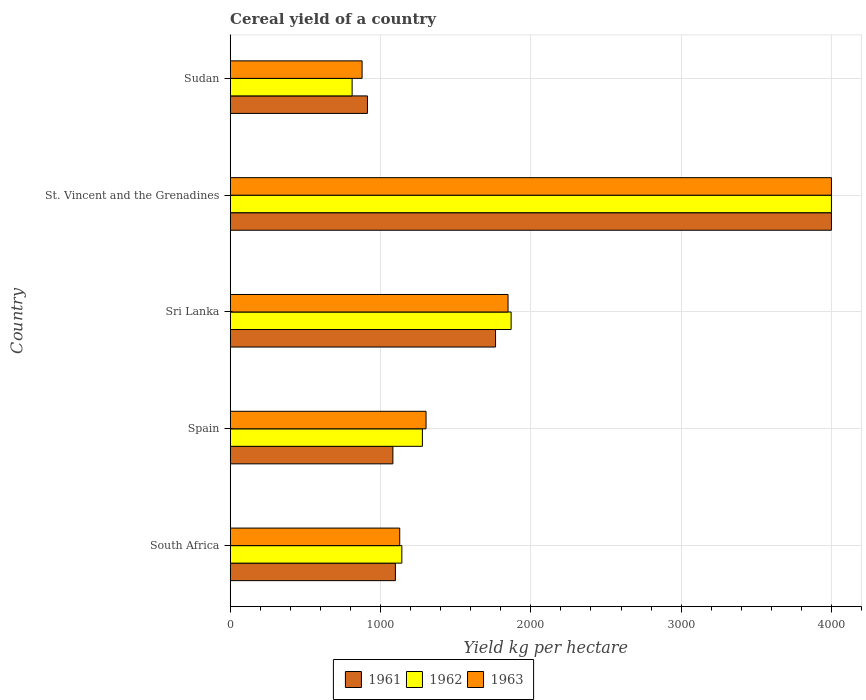Are the number of bars on each tick of the Y-axis equal?
Offer a terse response. Yes. What is the label of the 4th group of bars from the top?
Keep it short and to the point. Spain. In how many cases, is the number of bars for a given country not equal to the number of legend labels?
Your answer should be very brief. 0. What is the total cereal yield in 1963 in Sudan?
Offer a terse response. 877.56. Across all countries, what is the maximum total cereal yield in 1962?
Your response must be concise. 4000. Across all countries, what is the minimum total cereal yield in 1962?
Offer a terse response. 811.23. In which country was the total cereal yield in 1961 maximum?
Ensure brevity in your answer.  St. Vincent and the Grenadines. In which country was the total cereal yield in 1962 minimum?
Make the answer very short. Sudan. What is the total total cereal yield in 1962 in the graph?
Offer a very short reply. 9101.1. What is the difference between the total cereal yield in 1961 in Spain and that in Sudan?
Offer a terse response. 169.38. What is the difference between the total cereal yield in 1961 in Sri Lanka and the total cereal yield in 1962 in Spain?
Provide a short and direct response. 486.72. What is the average total cereal yield in 1961 per country?
Provide a short and direct response. 1772.03. What is the difference between the total cereal yield in 1961 and total cereal yield in 1963 in St. Vincent and the Grenadines?
Give a very brief answer. 0. What is the ratio of the total cereal yield in 1962 in South Africa to that in Sudan?
Ensure brevity in your answer.  1.41. What is the difference between the highest and the second highest total cereal yield in 1961?
Give a very brief answer. 2234.57. What is the difference between the highest and the lowest total cereal yield in 1962?
Provide a short and direct response. 3188.78. Is the sum of the total cereal yield in 1961 in Sri Lanka and St. Vincent and the Grenadines greater than the maximum total cereal yield in 1963 across all countries?
Provide a succinct answer. Yes. What does the 2nd bar from the top in South Africa represents?
Offer a terse response. 1962. Is it the case that in every country, the sum of the total cereal yield in 1963 and total cereal yield in 1962 is greater than the total cereal yield in 1961?
Offer a terse response. Yes. What is the difference between two consecutive major ticks on the X-axis?
Your answer should be very brief. 1000. Does the graph contain any zero values?
Offer a terse response. No. How many legend labels are there?
Give a very brief answer. 3. What is the title of the graph?
Ensure brevity in your answer.  Cereal yield of a country. Does "1991" appear as one of the legend labels in the graph?
Your answer should be very brief. No. What is the label or title of the X-axis?
Provide a succinct answer. Yield kg per hectare. What is the label or title of the Y-axis?
Provide a succinct answer. Country. What is the Yield kg per hectare of 1961 in South Africa?
Your answer should be compact. 1099.14. What is the Yield kg per hectare in 1962 in South Africa?
Keep it short and to the point. 1142.06. What is the Yield kg per hectare in 1963 in South Africa?
Provide a short and direct response. 1128.02. What is the Yield kg per hectare of 1961 in Spain?
Keep it short and to the point. 1082.47. What is the Yield kg per hectare in 1962 in Spain?
Offer a very short reply. 1278.71. What is the Yield kg per hectare in 1963 in Spain?
Give a very brief answer. 1303.07. What is the Yield kg per hectare in 1961 in Sri Lanka?
Give a very brief answer. 1765.43. What is the Yield kg per hectare in 1962 in Sri Lanka?
Your response must be concise. 1869.1. What is the Yield kg per hectare in 1963 in Sri Lanka?
Your answer should be compact. 1848.43. What is the Yield kg per hectare in 1961 in St. Vincent and the Grenadines?
Ensure brevity in your answer.  4000. What is the Yield kg per hectare of 1962 in St. Vincent and the Grenadines?
Ensure brevity in your answer.  4000. What is the Yield kg per hectare in 1963 in St. Vincent and the Grenadines?
Provide a short and direct response. 4000. What is the Yield kg per hectare of 1961 in Sudan?
Make the answer very short. 913.1. What is the Yield kg per hectare of 1962 in Sudan?
Your answer should be compact. 811.23. What is the Yield kg per hectare in 1963 in Sudan?
Your answer should be compact. 877.56. Across all countries, what is the maximum Yield kg per hectare of 1961?
Offer a terse response. 4000. Across all countries, what is the maximum Yield kg per hectare of 1962?
Ensure brevity in your answer.  4000. Across all countries, what is the maximum Yield kg per hectare of 1963?
Provide a succinct answer. 4000. Across all countries, what is the minimum Yield kg per hectare of 1961?
Make the answer very short. 913.1. Across all countries, what is the minimum Yield kg per hectare in 1962?
Your answer should be very brief. 811.23. Across all countries, what is the minimum Yield kg per hectare of 1963?
Offer a very short reply. 877.56. What is the total Yield kg per hectare of 1961 in the graph?
Give a very brief answer. 8860.14. What is the total Yield kg per hectare in 1962 in the graph?
Provide a succinct answer. 9101.1. What is the total Yield kg per hectare of 1963 in the graph?
Your answer should be very brief. 9157.08. What is the difference between the Yield kg per hectare in 1961 in South Africa and that in Spain?
Provide a short and direct response. 16.67. What is the difference between the Yield kg per hectare in 1962 in South Africa and that in Spain?
Your answer should be very brief. -136.65. What is the difference between the Yield kg per hectare in 1963 in South Africa and that in Spain?
Ensure brevity in your answer.  -175.04. What is the difference between the Yield kg per hectare in 1961 in South Africa and that in Sri Lanka?
Give a very brief answer. -666.29. What is the difference between the Yield kg per hectare in 1962 in South Africa and that in Sri Lanka?
Your answer should be very brief. -727.04. What is the difference between the Yield kg per hectare in 1963 in South Africa and that in Sri Lanka?
Your response must be concise. -720.41. What is the difference between the Yield kg per hectare of 1961 in South Africa and that in St. Vincent and the Grenadines?
Your answer should be very brief. -2900.86. What is the difference between the Yield kg per hectare of 1962 in South Africa and that in St. Vincent and the Grenadines?
Provide a succinct answer. -2857.94. What is the difference between the Yield kg per hectare in 1963 in South Africa and that in St. Vincent and the Grenadines?
Offer a very short reply. -2871.98. What is the difference between the Yield kg per hectare in 1961 in South Africa and that in Sudan?
Keep it short and to the point. 186.05. What is the difference between the Yield kg per hectare in 1962 in South Africa and that in Sudan?
Give a very brief answer. 330.84. What is the difference between the Yield kg per hectare of 1963 in South Africa and that in Sudan?
Keep it short and to the point. 250.46. What is the difference between the Yield kg per hectare of 1961 in Spain and that in Sri Lanka?
Offer a terse response. -682.96. What is the difference between the Yield kg per hectare in 1962 in Spain and that in Sri Lanka?
Your answer should be very brief. -590.39. What is the difference between the Yield kg per hectare of 1963 in Spain and that in Sri Lanka?
Ensure brevity in your answer.  -545.36. What is the difference between the Yield kg per hectare in 1961 in Spain and that in St. Vincent and the Grenadines?
Offer a terse response. -2917.53. What is the difference between the Yield kg per hectare in 1962 in Spain and that in St. Vincent and the Grenadines?
Offer a terse response. -2721.29. What is the difference between the Yield kg per hectare of 1963 in Spain and that in St. Vincent and the Grenadines?
Provide a short and direct response. -2696.93. What is the difference between the Yield kg per hectare of 1961 in Spain and that in Sudan?
Your response must be concise. 169.38. What is the difference between the Yield kg per hectare in 1962 in Spain and that in Sudan?
Your answer should be very brief. 467.49. What is the difference between the Yield kg per hectare of 1963 in Spain and that in Sudan?
Your answer should be very brief. 425.5. What is the difference between the Yield kg per hectare of 1961 in Sri Lanka and that in St. Vincent and the Grenadines?
Your answer should be very brief. -2234.57. What is the difference between the Yield kg per hectare of 1962 in Sri Lanka and that in St. Vincent and the Grenadines?
Provide a short and direct response. -2130.9. What is the difference between the Yield kg per hectare in 1963 in Sri Lanka and that in St. Vincent and the Grenadines?
Provide a short and direct response. -2151.57. What is the difference between the Yield kg per hectare in 1961 in Sri Lanka and that in Sudan?
Your answer should be very brief. 852.33. What is the difference between the Yield kg per hectare in 1962 in Sri Lanka and that in Sudan?
Ensure brevity in your answer.  1057.88. What is the difference between the Yield kg per hectare of 1963 in Sri Lanka and that in Sudan?
Provide a succinct answer. 970.87. What is the difference between the Yield kg per hectare in 1961 in St. Vincent and the Grenadines and that in Sudan?
Your answer should be very brief. 3086.9. What is the difference between the Yield kg per hectare of 1962 in St. Vincent and the Grenadines and that in Sudan?
Give a very brief answer. 3188.78. What is the difference between the Yield kg per hectare of 1963 in St. Vincent and the Grenadines and that in Sudan?
Your response must be concise. 3122.44. What is the difference between the Yield kg per hectare of 1961 in South Africa and the Yield kg per hectare of 1962 in Spain?
Provide a succinct answer. -179.57. What is the difference between the Yield kg per hectare in 1961 in South Africa and the Yield kg per hectare in 1963 in Spain?
Ensure brevity in your answer.  -203.92. What is the difference between the Yield kg per hectare in 1962 in South Africa and the Yield kg per hectare in 1963 in Spain?
Make the answer very short. -161. What is the difference between the Yield kg per hectare of 1961 in South Africa and the Yield kg per hectare of 1962 in Sri Lanka?
Your response must be concise. -769.96. What is the difference between the Yield kg per hectare of 1961 in South Africa and the Yield kg per hectare of 1963 in Sri Lanka?
Provide a succinct answer. -749.29. What is the difference between the Yield kg per hectare of 1962 in South Africa and the Yield kg per hectare of 1963 in Sri Lanka?
Your response must be concise. -706.37. What is the difference between the Yield kg per hectare of 1961 in South Africa and the Yield kg per hectare of 1962 in St. Vincent and the Grenadines?
Provide a short and direct response. -2900.86. What is the difference between the Yield kg per hectare in 1961 in South Africa and the Yield kg per hectare in 1963 in St. Vincent and the Grenadines?
Offer a terse response. -2900.86. What is the difference between the Yield kg per hectare in 1962 in South Africa and the Yield kg per hectare in 1963 in St. Vincent and the Grenadines?
Provide a short and direct response. -2857.94. What is the difference between the Yield kg per hectare of 1961 in South Africa and the Yield kg per hectare of 1962 in Sudan?
Make the answer very short. 287.92. What is the difference between the Yield kg per hectare of 1961 in South Africa and the Yield kg per hectare of 1963 in Sudan?
Offer a very short reply. 221.58. What is the difference between the Yield kg per hectare of 1962 in South Africa and the Yield kg per hectare of 1963 in Sudan?
Ensure brevity in your answer.  264.5. What is the difference between the Yield kg per hectare of 1961 in Spain and the Yield kg per hectare of 1962 in Sri Lanka?
Your response must be concise. -786.63. What is the difference between the Yield kg per hectare in 1961 in Spain and the Yield kg per hectare in 1963 in Sri Lanka?
Provide a short and direct response. -765.96. What is the difference between the Yield kg per hectare in 1962 in Spain and the Yield kg per hectare in 1963 in Sri Lanka?
Provide a succinct answer. -569.72. What is the difference between the Yield kg per hectare of 1961 in Spain and the Yield kg per hectare of 1962 in St. Vincent and the Grenadines?
Your answer should be compact. -2917.53. What is the difference between the Yield kg per hectare of 1961 in Spain and the Yield kg per hectare of 1963 in St. Vincent and the Grenadines?
Your response must be concise. -2917.53. What is the difference between the Yield kg per hectare of 1962 in Spain and the Yield kg per hectare of 1963 in St. Vincent and the Grenadines?
Offer a very short reply. -2721.29. What is the difference between the Yield kg per hectare in 1961 in Spain and the Yield kg per hectare in 1962 in Sudan?
Provide a succinct answer. 271.25. What is the difference between the Yield kg per hectare of 1961 in Spain and the Yield kg per hectare of 1963 in Sudan?
Your response must be concise. 204.91. What is the difference between the Yield kg per hectare of 1962 in Spain and the Yield kg per hectare of 1963 in Sudan?
Your response must be concise. 401.15. What is the difference between the Yield kg per hectare in 1961 in Sri Lanka and the Yield kg per hectare in 1962 in St. Vincent and the Grenadines?
Offer a very short reply. -2234.57. What is the difference between the Yield kg per hectare of 1961 in Sri Lanka and the Yield kg per hectare of 1963 in St. Vincent and the Grenadines?
Offer a very short reply. -2234.57. What is the difference between the Yield kg per hectare in 1962 in Sri Lanka and the Yield kg per hectare in 1963 in St. Vincent and the Grenadines?
Give a very brief answer. -2130.9. What is the difference between the Yield kg per hectare of 1961 in Sri Lanka and the Yield kg per hectare of 1962 in Sudan?
Provide a short and direct response. 954.2. What is the difference between the Yield kg per hectare in 1961 in Sri Lanka and the Yield kg per hectare in 1963 in Sudan?
Your answer should be very brief. 887.87. What is the difference between the Yield kg per hectare in 1962 in Sri Lanka and the Yield kg per hectare in 1963 in Sudan?
Your answer should be very brief. 991.54. What is the difference between the Yield kg per hectare in 1961 in St. Vincent and the Grenadines and the Yield kg per hectare in 1962 in Sudan?
Your answer should be compact. 3188.78. What is the difference between the Yield kg per hectare in 1961 in St. Vincent and the Grenadines and the Yield kg per hectare in 1963 in Sudan?
Provide a short and direct response. 3122.44. What is the difference between the Yield kg per hectare in 1962 in St. Vincent and the Grenadines and the Yield kg per hectare in 1963 in Sudan?
Provide a succinct answer. 3122.44. What is the average Yield kg per hectare of 1961 per country?
Offer a very short reply. 1772.03. What is the average Yield kg per hectare in 1962 per country?
Your answer should be very brief. 1820.22. What is the average Yield kg per hectare of 1963 per country?
Your answer should be compact. 1831.42. What is the difference between the Yield kg per hectare in 1961 and Yield kg per hectare in 1962 in South Africa?
Give a very brief answer. -42.92. What is the difference between the Yield kg per hectare of 1961 and Yield kg per hectare of 1963 in South Africa?
Provide a succinct answer. -28.88. What is the difference between the Yield kg per hectare of 1962 and Yield kg per hectare of 1963 in South Africa?
Give a very brief answer. 14.04. What is the difference between the Yield kg per hectare of 1961 and Yield kg per hectare of 1962 in Spain?
Your answer should be very brief. -196.24. What is the difference between the Yield kg per hectare in 1961 and Yield kg per hectare in 1963 in Spain?
Provide a short and direct response. -220.59. What is the difference between the Yield kg per hectare of 1962 and Yield kg per hectare of 1963 in Spain?
Your answer should be compact. -24.36. What is the difference between the Yield kg per hectare in 1961 and Yield kg per hectare in 1962 in Sri Lanka?
Ensure brevity in your answer.  -103.67. What is the difference between the Yield kg per hectare in 1961 and Yield kg per hectare in 1963 in Sri Lanka?
Make the answer very short. -83. What is the difference between the Yield kg per hectare in 1962 and Yield kg per hectare in 1963 in Sri Lanka?
Make the answer very short. 20.67. What is the difference between the Yield kg per hectare in 1961 and Yield kg per hectare in 1962 in Sudan?
Keep it short and to the point. 101.87. What is the difference between the Yield kg per hectare in 1961 and Yield kg per hectare in 1963 in Sudan?
Your response must be concise. 35.53. What is the difference between the Yield kg per hectare in 1962 and Yield kg per hectare in 1963 in Sudan?
Offer a terse response. -66.34. What is the ratio of the Yield kg per hectare of 1961 in South Africa to that in Spain?
Ensure brevity in your answer.  1.02. What is the ratio of the Yield kg per hectare in 1962 in South Africa to that in Spain?
Provide a short and direct response. 0.89. What is the ratio of the Yield kg per hectare of 1963 in South Africa to that in Spain?
Your answer should be very brief. 0.87. What is the ratio of the Yield kg per hectare of 1961 in South Africa to that in Sri Lanka?
Your answer should be very brief. 0.62. What is the ratio of the Yield kg per hectare in 1962 in South Africa to that in Sri Lanka?
Your answer should be very brief. 0.61. What is the ratio of the Yield kg per hectare of 1963 in South Africa to that in Sri Lanka?
Give a very brief answer. 0.61. What is the ratio of the Yield kg per hectare of 1961 in South Africa to that in St. Vincent and the Grenadines?
Ensure brevity in your answer.  0.27. What is the ratio of the Yield kg per hectare of 1962 in South Africa to that in St. Vincent and the Grenadines?
Make the answer very short. 0.29. What is the ratio of the Yield kg per hectare in 1963 in South Africa to that in St. Vincent and the Grenadines?
Make the answer very short. 0.28. What is the ratio of the Yield kg per hectare of 1961 in South Africa to that in Sudan?
Provide a short and direct response. 1.2. What is the ratio of the Yield kg per hectare in 1962 in South Africa to that in Sudan?
Offer a very short reply. 1.41. What is the ratio of the Yield kg per hectare of 1963 in South Africa to that in Sudan?
Provide a succinct answer. 1.29. What is the ratio of the Yield kg per hectare in 1961 in Spain to that in Sri Lanka?
Ensure brevity in your answer.  0.61. What is the ratio of the Yield kg per hectare of 1962 in Spain to that in Sri Lanka?
Ensure brevity in your answer.  0.68. What is the ratio of the Yield kg per hectare in 1963 in Spain to that in Sri Lanka?
Provide a succinct answer. 0.7. What is the ratio of the Yield kg per hectare in 1961 in Spain to that in St. Vincent and the Grenadines?
Your response must be concise. 0.27. What is the ratio of the Yield kg per hectare of 1962 in Spain to that in St. Vincent and the Grenadines?
Your response must be concise. 0.32. What is the ratio of the Yield kg per hectare in 1963 in Spain to that in St. Vincent and the Grenadines?
Make the answer very short. 0.33. What is the ratio of the Yield kg per hectare in 1961 in Spain to that in Sudan?
Provide a short and direct response. 1.19. What is the ratio of the Yield kg per hectare of 1962 in Spain to that in Sudan?
Keep it short and to the point. 1.58. What is the ratio of the Yield kg per hectare of 1963 in Spain to that in Sudan?
Offer a very short reply. 1.48. What is the ratio of the Yield kg per hectare in 1961 in Sri Lanka to that in St. Vincent and the Grenadines?
Your answer should be compact. 0.44. What is the ratio of the Yield kg per hectare in 1962 in Sri Lanka to that in St. Vincent and the Grenadines?
Provide a succinct answer. 0.47. What is the ratio of the Yield kg per hectare of 1963 in Sri Lanka to that in St. Vincent and the Grenadines?
Your answer should be very brief. 0.46. What is the ratio of the Yield kg per hectare in 1961 in Sri Lanka to that in Sudan?
Offer a very short reply. 1.93. What is the ratio of the Yield kg per hectare of 1962 in Sri Lanka to that in Sudan?
Offer a terse response. 2.3. What is the ratio of the Yield kg per hectare in 1963 in Sri Lanka to that in Sudan?
Offer a terse response. 2.11. What is the ratio of the Yield kg per hectare in 1961 in St. Vincent and the Grenadines to that in Sudan?
Provide a succinct answer. 4.38. What is the ratio of the Yield kg per hectare in 1962 in St. Vincent and the Grenadines to that in Sudan?
Provide a short and direct response. 4.93. What is the ratio of the Yield kg per hectare in 1963 in St. Vincent and the Grenadines to that in Sudan?
Provide a succinct answer. 4.56. What is the difference between the highest and the second highest Yield kg per hectare of 1961?
Your answer should be very brief. 2234.57. What is the difference between the highest and the second highest Yield kg per hectare in 1962?
Provide a succinct answer. 2130.9. What is the difference between the highest and the second highest Yield kg per hectare of 1963?
Offer a very short reply. 2151.57. What is the difference between the highest and the lowest Yield kg per hectare in 1961?
Ensure brevity in your answer.  3086.9. What is the difference between the highest and the lowest Yield kg per hectare of 1962?
Make the answer very short. 3188.78. What is the difference between the highest and the lowest Yield kg per hectare in 1963?
Your response must be concise. 3122.44. 